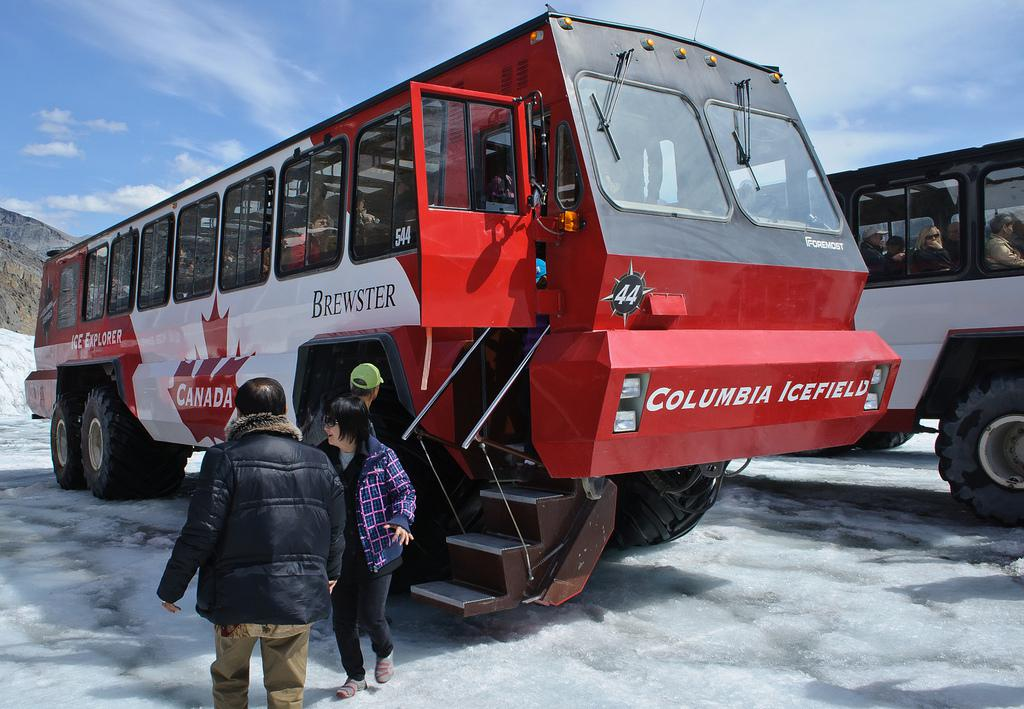Question: who is outside the vehicle?
Choices:
A. Two men and a woman.
B. A boy.
C. A girl.
D. A doctor.
Answer with the letter. Answer: A Question: what country is mentioned on the vehicle?
Choices:
A. Brazil.
B. Usa.
C. Australia.
D. Canada.
Answer with the letter. Answer: D Question: how may people are outside the vehicle?
Choices:
A. Four.
B. Six.
C. Two.
D. Three.
Answer with the letter. Answer: D Question: what colors are on the vehicle?
Choices:
A. Yellow and green.
B. Black ad white.
C. Brown and white.
D. Red and white.
Answer with the letter. Answer: D Question: why are the tires so large?
Choices:
A. To travel on ice and snow.
B. To avoid getting stuck in mud.
C. To support the weight being carried.
D. To help the car from falling on rocks.
Answer with the letter. Answer: A Question: what is next to the vehicle?
Choices:
A. Another vehicle.
B. A bike.
C. Skaters.
D. A tall building.
Answer with the letter. Answer: A Question: what symbol is on the bus?
Choices:
A. A peace sign.
B. An American eagle.
C. A canadian leaf.
D. A hashtag.
Answer with the letter. Answer: C Question: what is parked on the snow?
Choices:
A. A sled.
B. A car.
C. A skidoo.
D. A bus.
Answer with the letter. Answer: D Question: how many buses are in the lot?
Choices:
A. Two buses.
B. Three buses.
C. Four buses.
D. Five buses.
Answer with the letter. Answer: A Question: what are the buses doing in the lot?
Choices:
A. They are parked.
B. They are being washed.
C. They are waiting for passengers.
D. They are getting gas.
Answer with the letter. Answer: A Question: what word is on the side of the bus?
Choices:
A. Brewster.
B. Transportation.
C. Greyhound.
D. Mexico.
Answer with the letter. Answer: A Question: what is in the sky?
Choices:
A. The sun.
B. The moon.
C. A few clouds.
D. An airplane.
Answer with the letter. Answer: C Question: what color are the clouds?
Choices:
A. They are gray.
B. They are black.
C. They are white.
D. They are cream.
Answer with the letter. Answer: C Question: what do the stairs on the bus do?
Choices:
A. They extend and retract.
B. Allow people to climb on.
C. They just sit there.
D. Trip people.
Answer with the letter. Answer: A Question: what is the woman wearing?
Choices:
A. A lovely dress.
B. A plaid jacket.
C. A light cardigan.
D. A pant suit.
Answer with the letter. Answer: B Question: what kind of pants is the man wearing?
Choices:
A. Dress pants.
B. Parachute pants.
C. Khaki pants.
D. He's not wearing any pants.
Answer with the letter. Answer: C Question: what appears on the front bumper?
Choices:
A. A license plate.
B. A vanity plate.
C. Icefield.
D. The car brand's logo.
Answer with the letter. Answer: C Question: how tall are the buses?
Choices:
A. Very tall.
B. Relatively short.
C. Somewhat tall.
D. They are not tall.
Answer with the letter. Answer: A Question: what are the passengers on the other bus doing?
Choices:
A. Talking with each other.
B. Looking out the windows.
C. Reading books.
D. Looking at the seat in front of them.
Answer with the letter. Answer: B Question: who is the woman walking toward?
Choices:
A. A kid.
B. A boy.
C. A elderly lady.
D. A man.
Answer with the letter. Answer: D Question: what hangs down over the windows?
Choices:
A. Sheets.
B. Shutters.
C. Chandaliers.
D. Windshield wipers.
Answer with the letter. Answer: D 